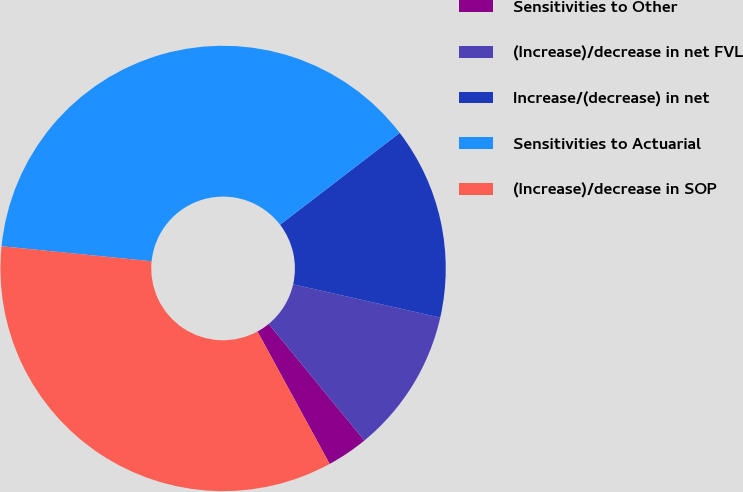<chart> <loc_0><loc_0><loc_500><loc_500><pie_chart><fcel>Sensitivities to Other<fcel>(Increase)/decrease in net FVL<fcel>Increase/(decrease) in net<fcel>Sensitivities to Actuarial<fcel>(Increase)/decrease in SOP<nl><fcel>3.0%<fcel>10.51%<fcel>13.96%<fcel>37.99%<fcel>34.53%<nl></chart> 